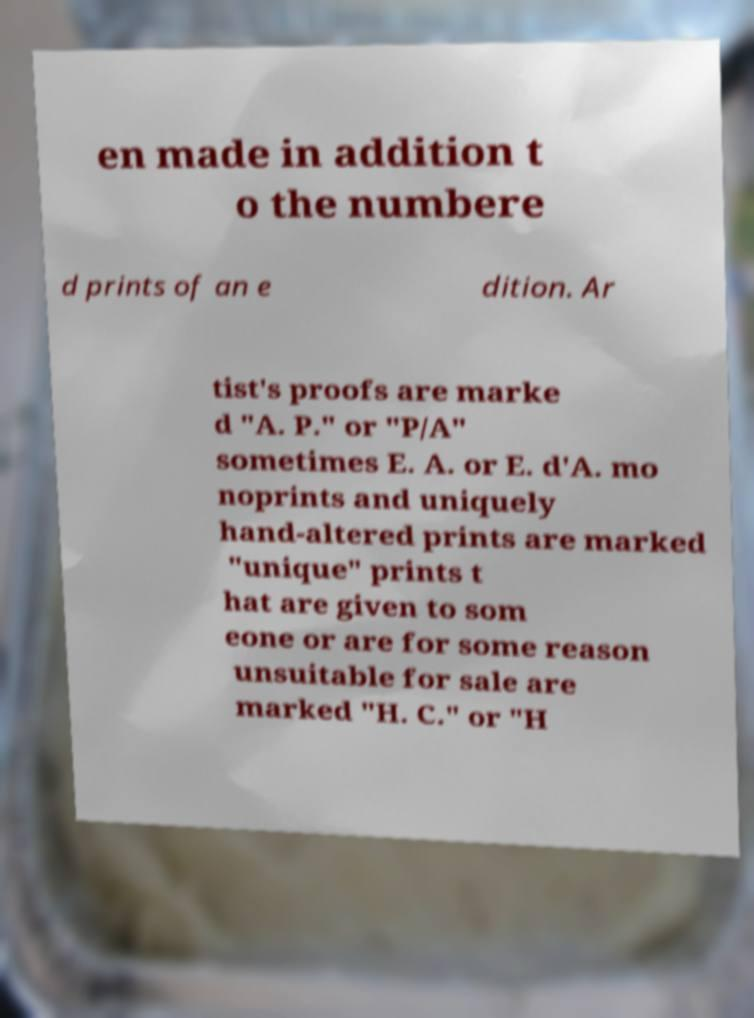I need the written content from this picture converted into text. Can you do that? en made in addition t o the numbere d prints of an e dition. Ar tist's proofs are marke d "A. P." or "P/A" sometimes E. A. or E. d'A. mo noprints and uniquely hand-altered prints are marked "unique" prints t hat are given to som eone or are for some reason unsuitable for sale are marked "H. C." or "H 